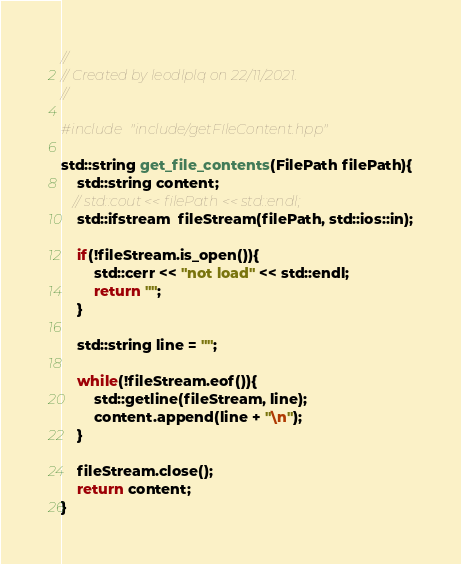<code> <loc_0><loc_0><loc_500><loc_500><_C++_>//
// Created by leodlplq on 22/11/2021.
//

#include "include/getFIleContent.hpp"

std::string get_file_contents(FilePath filePath){
    std::string content;
   // std::cout << filePath << std::endl;
    std::ifstream  fileStream(filePath, std::ios::in);

    if(!fileStream.is_open()){
        std::cerr << "not load" << std::endl;
        return "";
    }

    std::string line = "";

    while(!fileStream.eof()){
        std::getline(fileStream, line);
        content.append(line + "\n");
    }

    fileStream.close();
    return content;
}</code> 